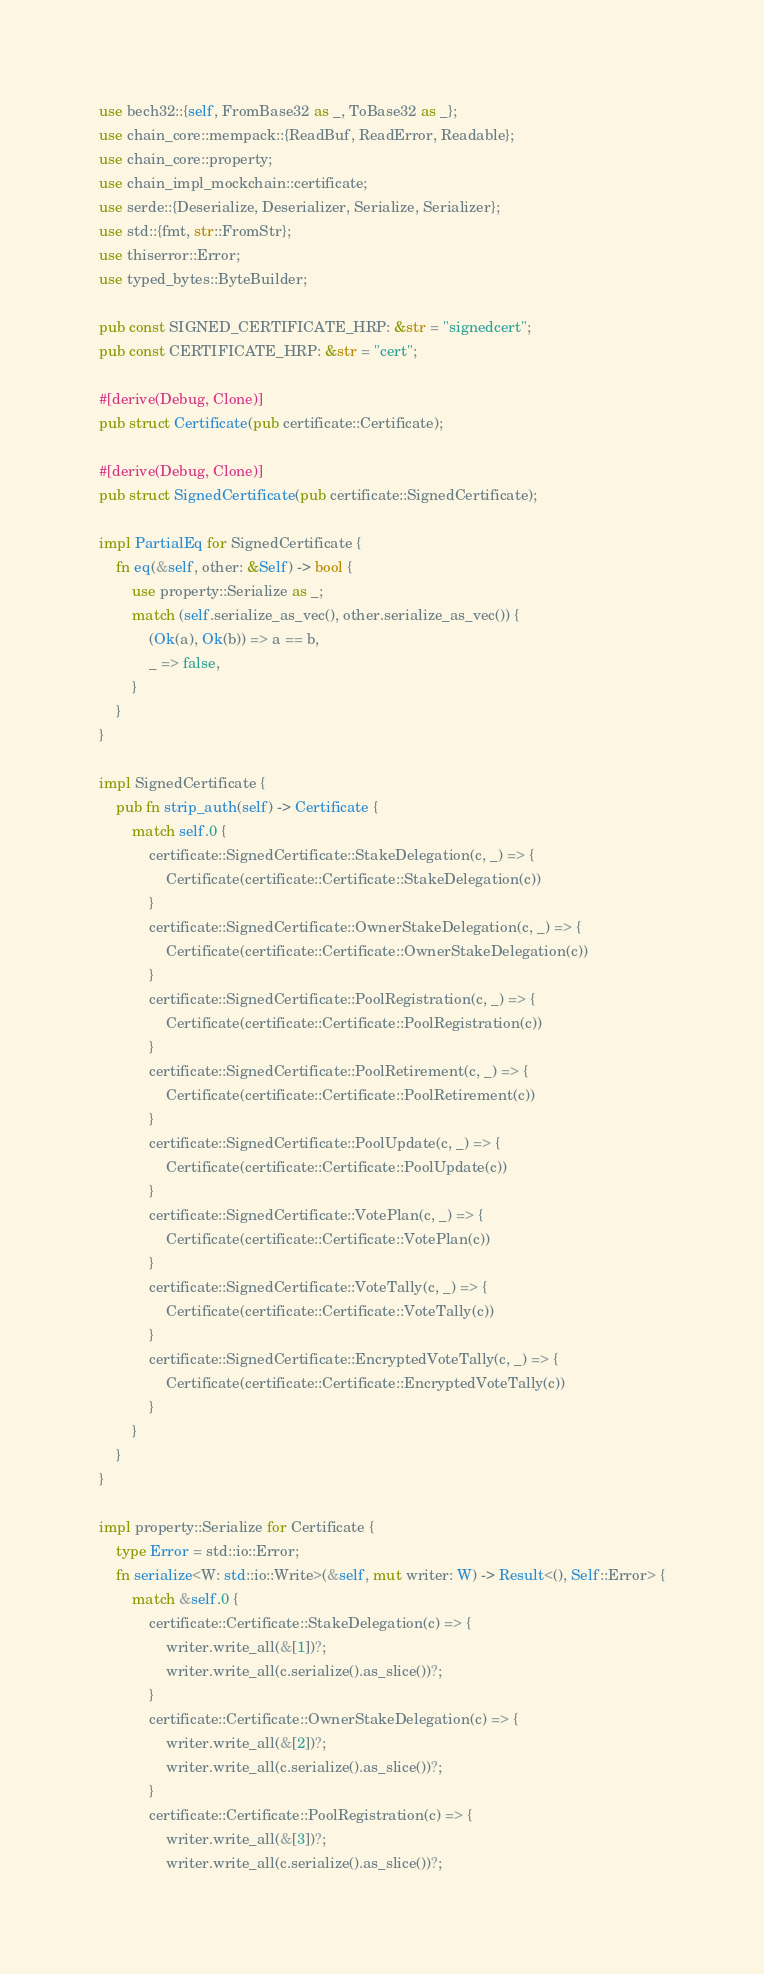<code> <loc_0><loc_0><loc_500><loc_500><_Rust_>use bech32::{self, FromBase32 as _, ToBase32 as _};
use chain_core::mempack::{ReadBuf, ReadError, Readable};
use chain_core::property;
use chain_impl_mockchain::certificate;
use serde::{Deserialize, Deserializer, Serialize, Serializer};
use std::{fmt, str::FromStr};
use thiserror::Error;
use typed_bytes::ByteBuilder;

pub const SIGNED_CERTIFICATE_HRP: &str = "signedcert";
pub const CERTIFICATE_HRP: &str = "cert";

#[derive(Debug, Clone)]
pub struct Certificate(pub certificate::Certificate);

#[derive(Debug, Clone)]
pub struct SignedCertificate(pub certificate::SignedCertificate);

impl PartialEq for SignedCertificate {
    fn eq(&self, other: &Self) -> bool {
        use property::Serialize as _;
        match (self.serialize_as_vec(), other.serialize_as_vec()) {
            (Ok(a), Ok(b)) => a == b,
            _ => false,
        }
    }
}

impl SignedCertificate {
    pub fn strip_auth(self) -> Certificate {
        match self.0 {
            certificate::SignedCertificate::StakeDelegation(c, _) => {
                Certificate(certificate::Certificate::StakeDelegation(c))
            }
            certificate::SignedCertificate::OwnerStakeDelegation(c, _) => {
                Certificate(certificate::Certificate::OwnerStakeDelegation(c))
            }
            certificate::SignedCertificate::PoolRegistration(c, _) => {
                Certificate(certificate::Certificate::PoolRegistration(c))
            }
            certificate::SignedCertificate::PoolRetirement(c, _) => {
                Certificate(certificate::Certificate::PoolRetirement(c))
            }
            certificate::SignedCertificate::PoolUpdate(c, _) => {
                Certificate(certificate::Certificate::PoolUpdate(c))
            }
            certificate::SignedCertificate::VotePlan(c, _) => {
                Certificate(certificate::Certificate::VotePlan(c))
            }
            certificate::SignedCertificate::VoteTally(c, _) => {
                Certificate(certificate::Certificate::VoteTally(c))
            }
            certificate::SignedCertificate::EncryptedVoteTally(c, _) => {
                Certificate(certificate::Certificate::EncryptedVoteTally(c))
            }
        }
    }
}

impl property::Serialize for Certificate {
    type Error = std::io::Error;
    fn serialize<W: std::io::Write>(&self, mut writer: W) -> Result<(), Self::Error> {
        match &self.0 {
            certificate::Certificate::StakeDelegation(c) => {
                writer.write_all(&[1])?;
                writer.write_all(c.serialize().as_slice())?;
            }
            certificate::Certificate::OwnerStakeDelegation(c) => {
                writer.write_all(&[2])?;
                writer.write_all(c.serialize().as_slice())?;
            }
            certificate::Certificate::PoolRegistration(c) => {
                writer.write_all(&[3])?;
                writer.write_all(c.serialize().as_slice())?;</code> 